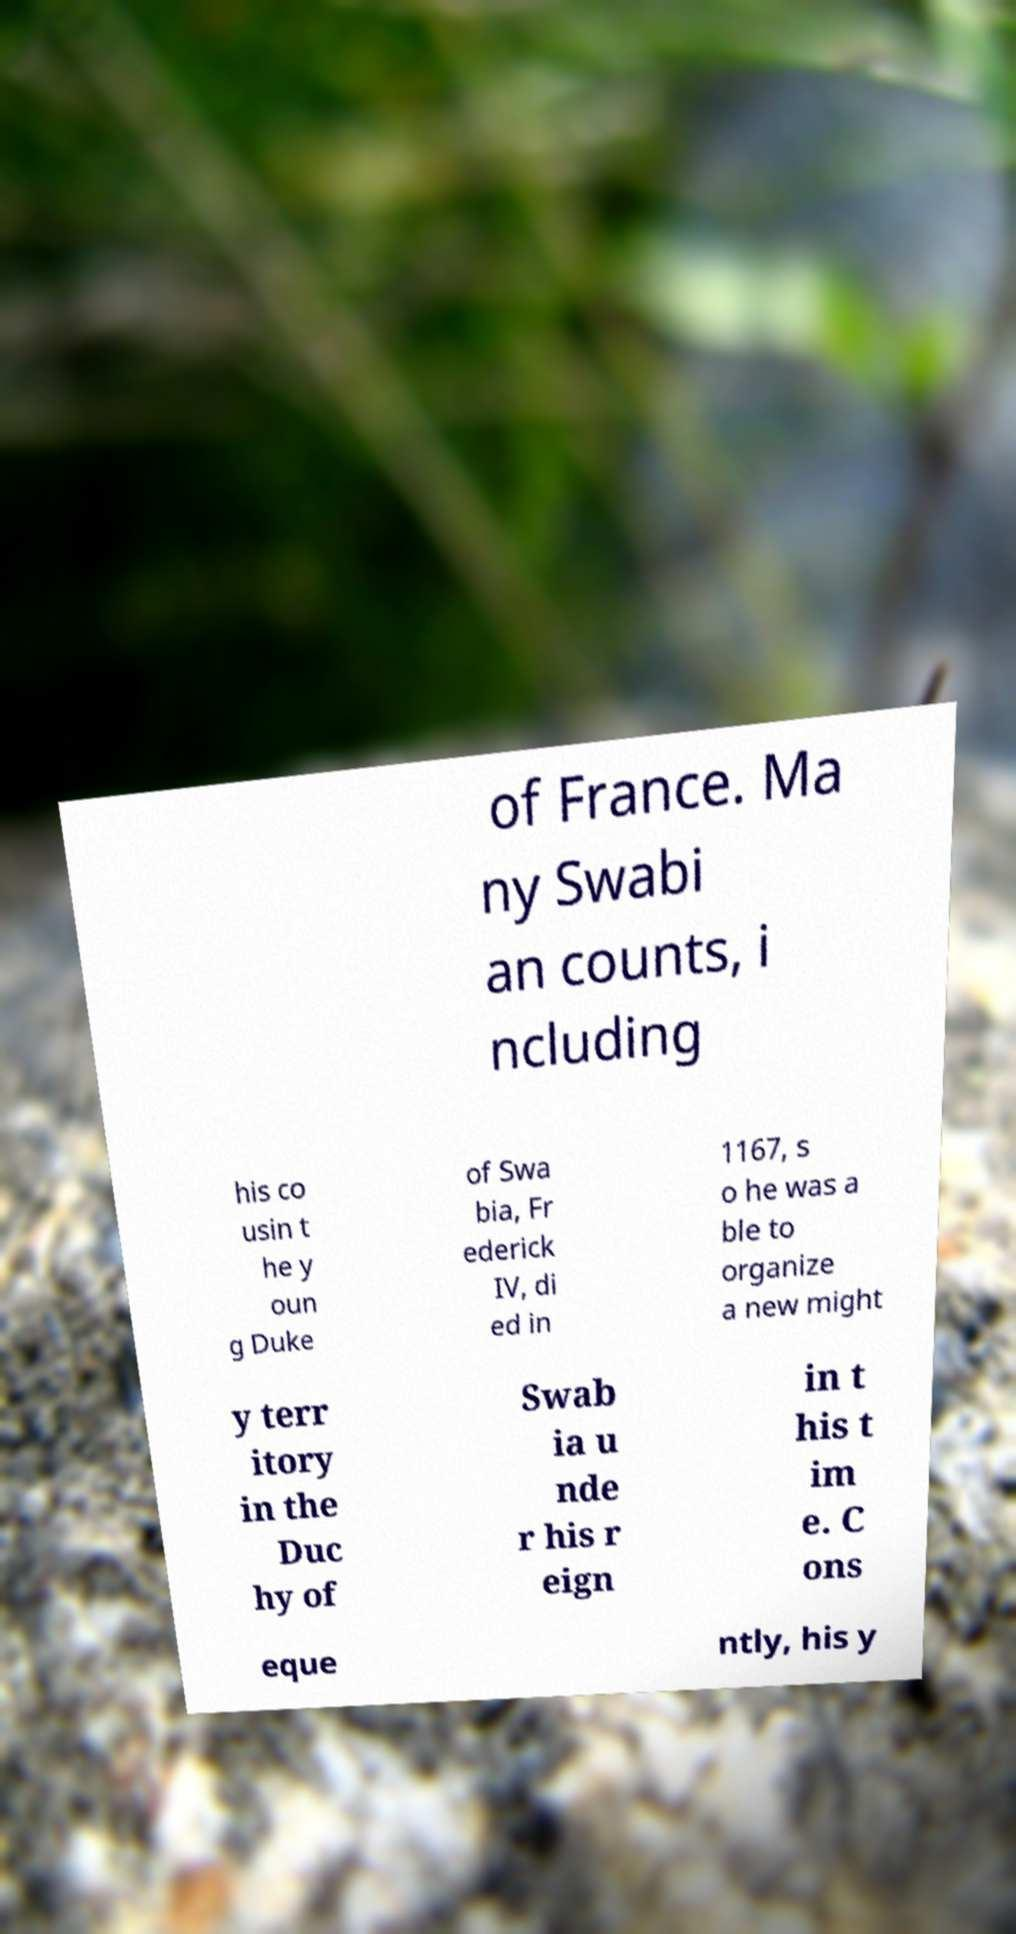I need the written content from this picture converted into text. Can you do that? of France. Ma ny Swabi an counts, i ncluding his co usin t he y oun g Duke of Swa bia, Fr ederick IV, di ed in 1167, s o he was a ble to organize a new might y terr itory in the Duc hy of Swab ia u nde r his r eign in t his t im e. C ons eque ntly, his y 